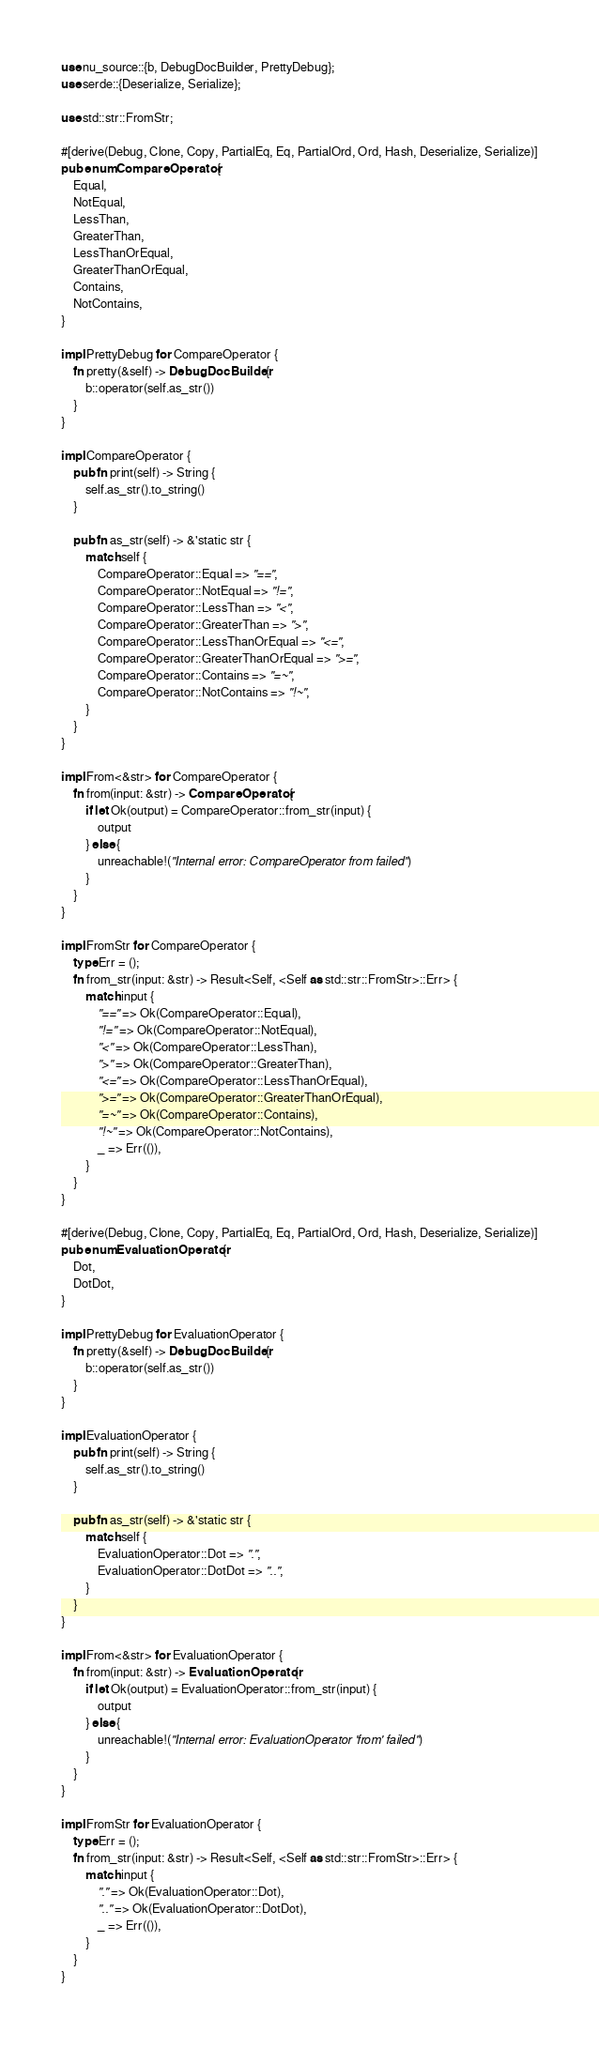Convert code to text. <code><loc_0><loc_0><loc_500><loc_500><_Rust_>use nu_source::{b, DebugDocBuilder, PrettyDebug};
use serde::{Deserialize, Serialize};

use std::str::FromStr;

#[derive(Debug, Clone, Copy, PartialEq, Eq, PartialOrd, Ord, Hash, Deserialize, Serialize)]
pub enum CompareOperator {
    Equal,
    NotEqual,
    LessThan,
    GreaterThan,
    LessThanOrEqual,
    GreaterThanOrEqual,
    Contains,
    NotContains,
}

impl PrettyDebug for CompareOperator {
    fn pretty(&self) -> DebugDocBuilder {
        b::operator(self.as_str())
    }
}

impl CompareOperator {
    pub fn print(self) -> String {
        self.as_str().to_string()
    }

    pub fn as_str(self) -> &'static str {
        match self {
            CompareOperator::Equal => "==",
            CompareOperator::NotEqual => "!=",
            CompareOperator::LessThan => "<",
            CompareOperator::GreaterThan => ">",
            CompareOperator::LessThanOrEqual => "<=",
            CompareOperator::GreaterThanOrEqual => ">=",
            CompareOperator::Contains => "=~",
            CompareOperator::NotContains => "!~",
        }
    }
}

impl From<&str> for CompareOperator {
    fn from(input: &str) -> CompareOperator {
        if let Ok(output) = CompareOperator::from_str(input) {
            output
        } else {
            unreachable!("Internal error: CompareOperator from failed")
        }
    }
}

impl FromStr for CompareOperator {
    type Err = ();
    fn from_str(input: &str) -> Result<Self, <Self as std::str::FromStr>::Err> {
        match input {
            "==" => Ok(CompareOperator::Equal),
            "!=" => Ok(CompareOperator::NotEqual),
            "<" => Ok(CompareOperator::LessThan),
            ">" => Ok(CompareOperator::GreaterThan),
            "<=" => Ok(CompareOperator::LessThanOrEqual),
            ">=" => Ok(CompareOperator::GreaterThanOrEqual),
            "=~" => Ok(CompareOperator::Contains),
            "!~" => Ok(CompareOperator::NotContains),
            _ => Err(()),
        }
    }
}

#[derive(Debug, Clone, Copy, PartialEq, Eq, PartialOrd, Ord, Hash, Deserialize, Serialize)]
pub enum EvaluationOperator {
    Dot,
    DotDot,
}

impl PrettyDebug for EvaluationOperator {
    fn pretty(&self) -> DebugDocBuilder {
        b::operator(self.as_str())
    }
}

impl EvaluationOperator {
    pub fn print(self) -> String {
        self.as_str().to_string()
    }

    pub fn as_str(self) -> &'static str {
        match self {
            EvaluationOperator::Dot => ".",
            EvaluationOperator::DotDot => "..",
        }
    }
}

impl From<&str> for EvaluationOperator {
    fn from(input: &str) -> EvaluationOperator {
        if let Ok(output) = EvaluationOperator::from_str(input) {
            output
        } else {
            unreachable!("Internal error: EvaluationOperator 'from' failed")
        }
    }
}

impl FromStr for EvaluationOperator {
    type Err = ();
    fn from_str(input: &str) -> Result<Self, <Self as std::str::FromStr>::Err> {
        match input {
            "." => Ok(EvaluationOperator::Dot),
            ".." => Ok(EvaluationOperator::DotDot),
            _ => Err(()),
        }
    }
}
</code> 